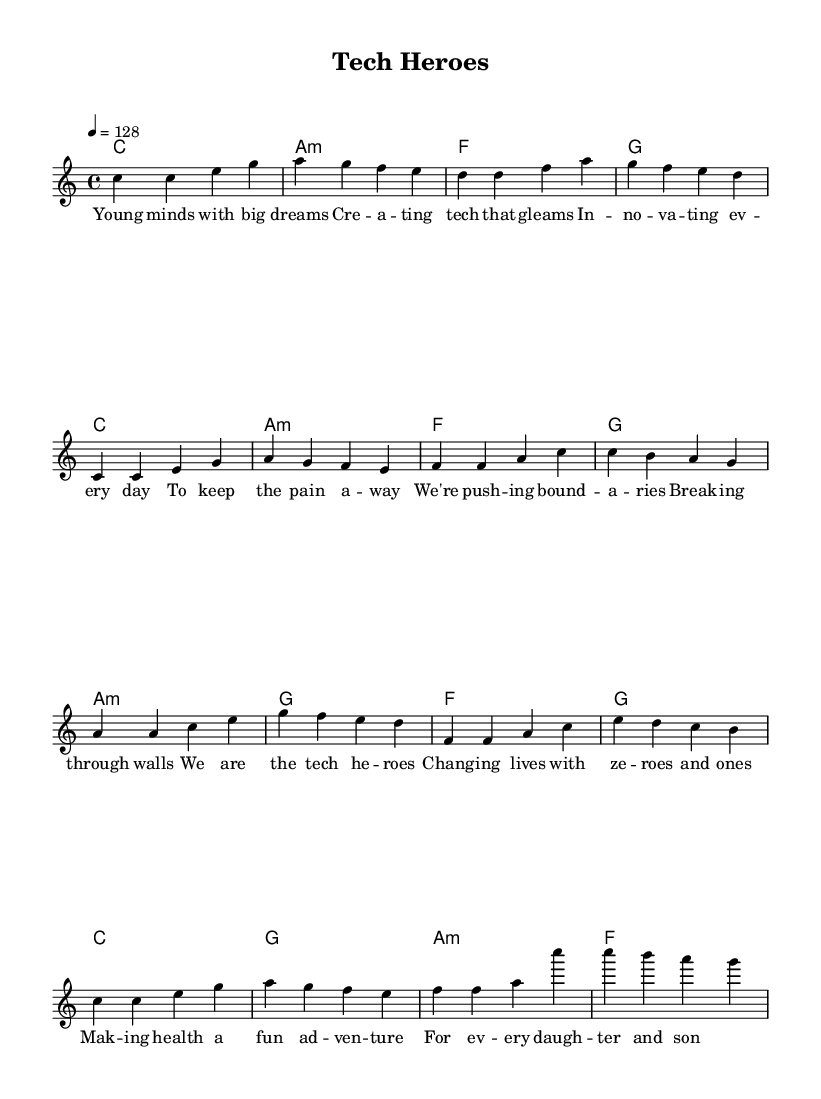What is the key signature of this music? The key signature is indicated at the beginning of the staff, showing no sharps or flats, which means it is C major.
Answer: C major What is the time signature of this piece? The time signature is displayed at the beginning, indicating it has four beats per measure, represented by 4/4.
Answer: 4/4 What is the tempo marking of this music? The tempo marking shows that the music should be played at a speed of 128 beats per minute, as indicated by the tempo notation.
Answer: 128 How many sections are in the song structure? The sheet music contains three distinct sections: Verse, Pre-Chorus, and Chorus; these can be identified by their respective labels and lyrics.
Answer: Three What are the harmonies used in the Chorus? The harmonies for the Chorus are listed in the chord mode section and show three chords: C, G, A minor, and F, which support the melody during this section.
Answer: C, G, A minor, F Which lyrical section mentions "technology"? The text "tech heroes" appears in the Chorus section, highlighting the theme of technology's impact and celebrating it.
Answer: Tech heroes How many measures are in the Verse section? By counting the segments in the Verse section of the melody, there are four measures in total, as indicated by the rhythmic groupings.
Answer: Four 